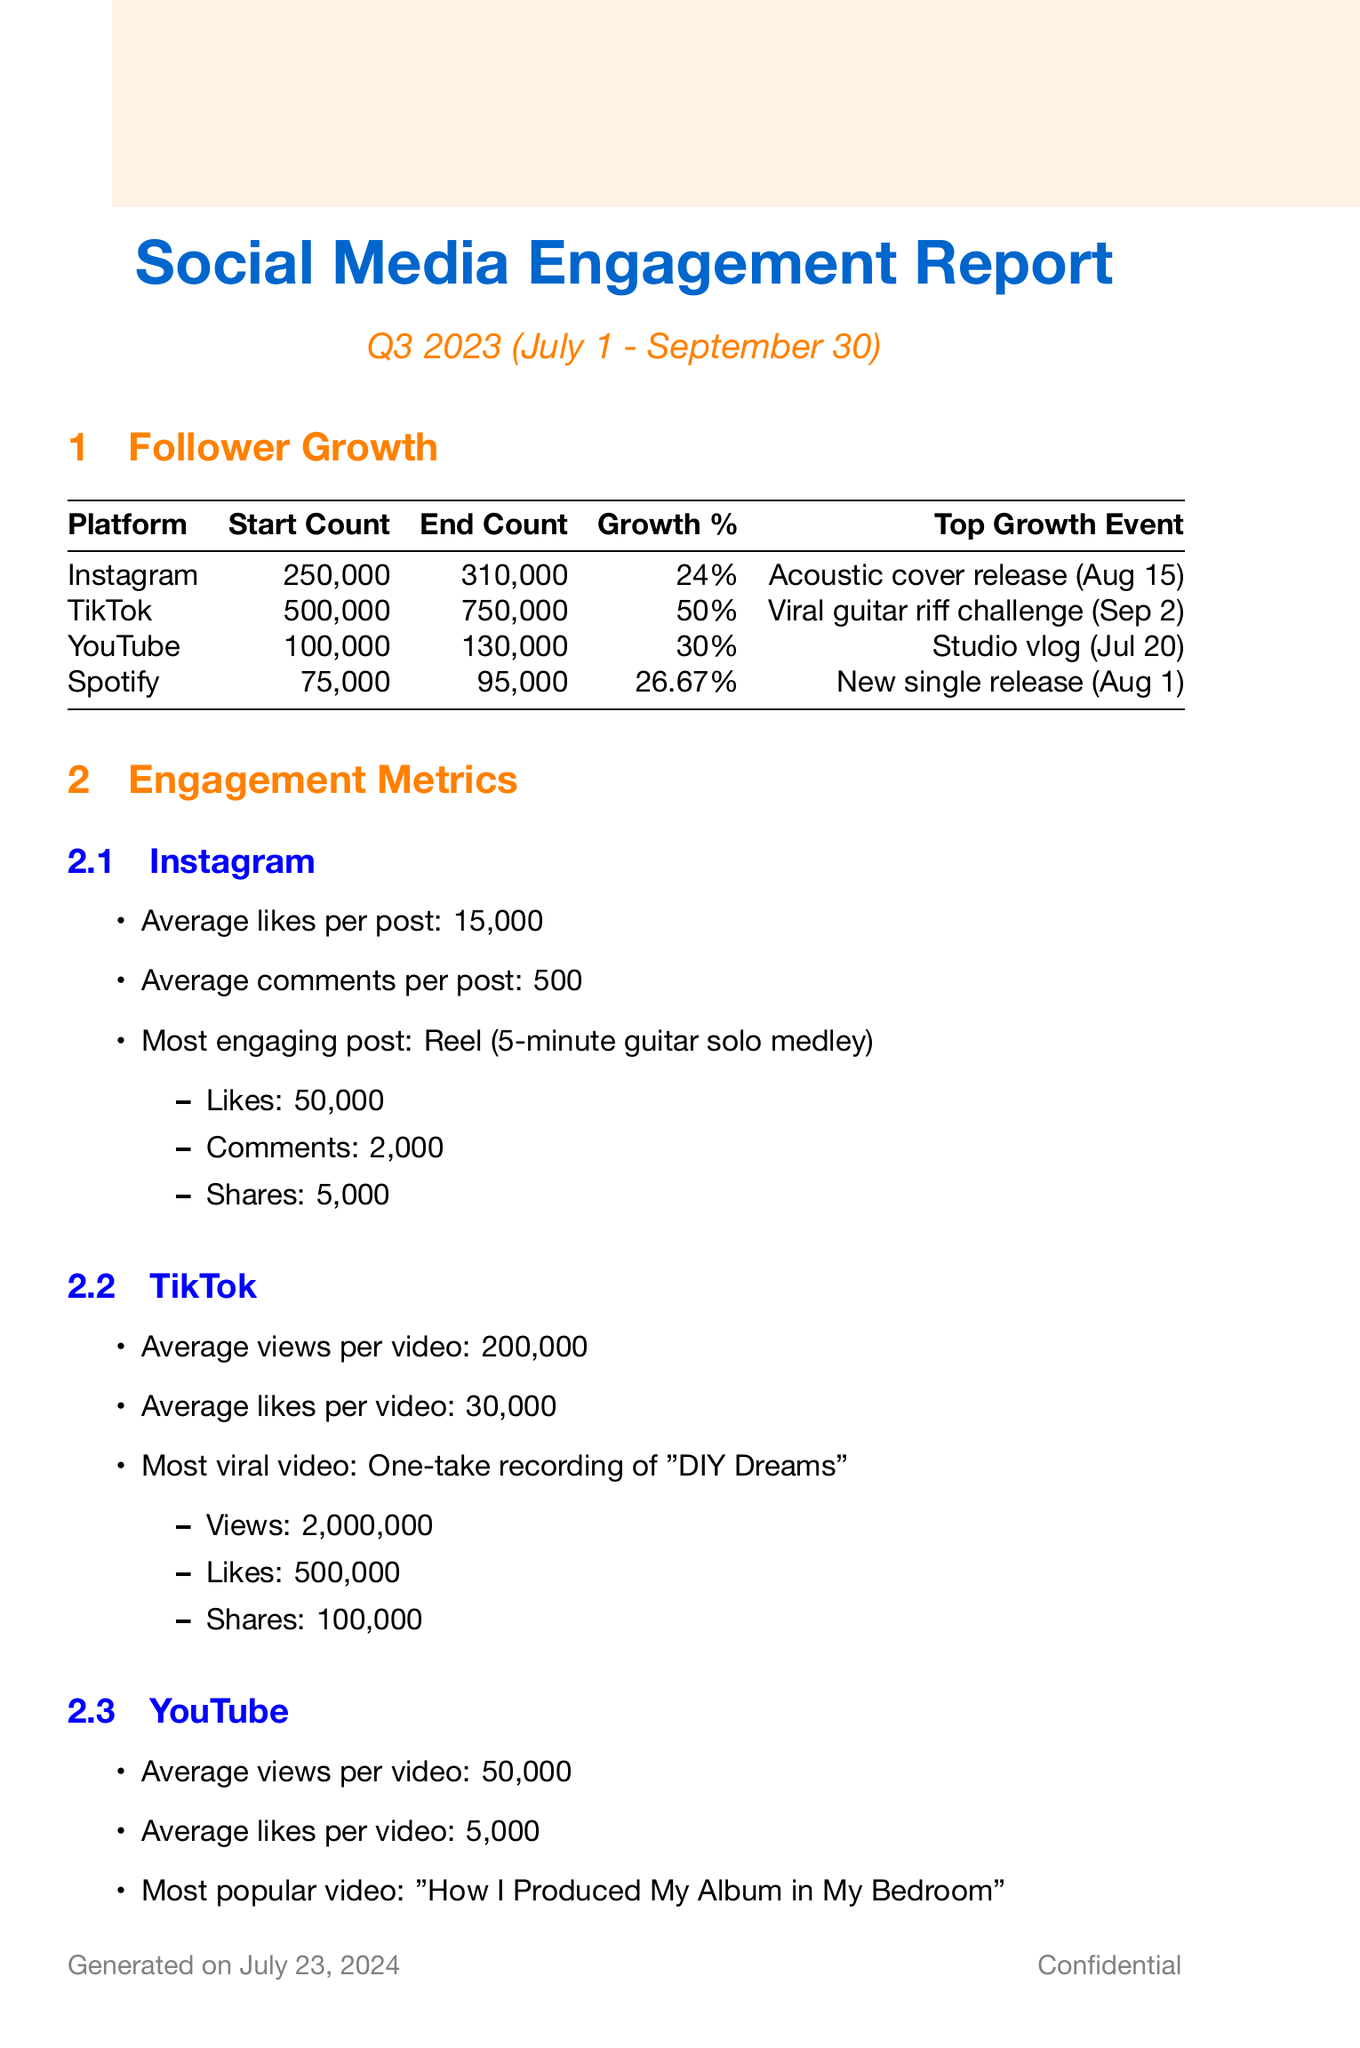What was the follower count at the start of Q3 2023 on Instagram? The document states the starting follower count on Instagram was 250,000.
Answer: 250,000 What was the top growth spike event on TikTok? The document indicates the top growth spike on TikTok was a viral guitar riff challenge on September 2.
Answer: Viral guitar riff challenge What is the average views per video on YouTube? According to the document, the average views per video on YouTube is 50,000.
Answer: 50,000 Which platform had the highest percentage growth in followers? The document shows TikTok had the highest percentage growth of 50%.
Answer: TikTok What are the two effective content types mentioned in the content strategy analysis? The document lists behind-the-scenes footage and live performances as effective content types.
Answer: Behind-the-scenes footage, Live performances What is the optimal posting time for Instagram? The document specifies the optimal posting time for Instagram as 8 PM - 10 PM.
Answer: 8 PM - 10 PM What was the engagement increase from Sarah McLachlan's guest appearance? The document states that Sarah McLachlan's appearance on Instagram Live resulted in a 200% engagement increase.
Answer: 200% How many new followers were gained from the Billboard article feature? The document notes that the Billboard feature resulted in a gain of 50,000 followers.
Answer: 50,000 What is the primary platform focus for upcoming strategies? The document mentions that the primary platform focus for upcoming strategies is TikTok.
Answer: TikTok 